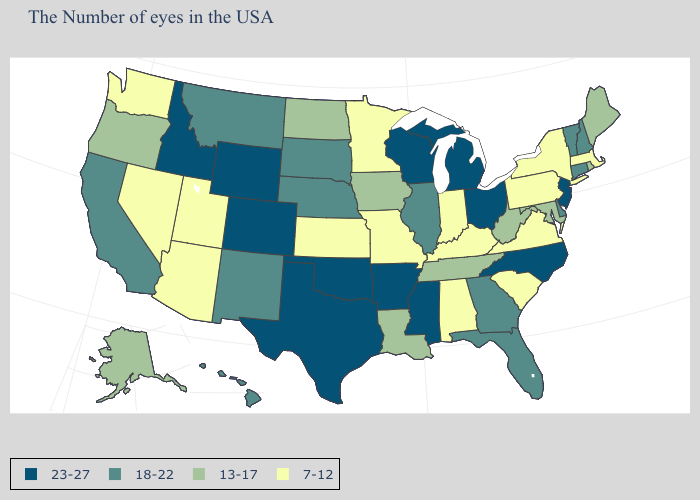Among the states that border North Carolina , does Tennessee have the highest value?
Concise answer only. No. Name the states that have a value in the range 18-22?
Answer briefly. New Hampshire, Vermont, Connecticut, Delaware, Florida, Georgia, Illinois, Nebraska, South Dakota, New Mexico, Montana, California, Hawaii. Which states have the lowest value in the USA?
Write a very short answer. Massachusetts, New York, Pennsylvania, Virginia, South Carolina, Kentucky, Indiana, Alabama, Missouri, Minnesota, Kansas, Utah, Arizona, Nevada, Washington. What is the value of Virginia?
Write a very short answer. 7-12. What is the lowest value in the Northeast?
Short answer required. 7-12. What is the value of Kentucky?
Answer briefly. 7-12. What is the value of Oregon?
Give a very brief answer. 13-17. What is the highest value in the USA?
Keep it brief. 23-27. Name the states that have a value in the range 7-12?
Concise answer only. Massachusetts, New York, Pennsylvania, Virginia, South Carolina, Kentucky, Indiana, Alabama, Missouri, Minnesota, Kansas, Utah, Arizona, Nevada, Washington. Does the first symbol in the legend represent the smallest category?
Give a very brief answer. No. Name the states that have a value in the range 7-12?
Give a very brief answer. Massachusetts, New York, Pennsylvania, Virginia, South Carolina, Kentucky, Indiana, Alabama, Missouri, Minnesota, Kansas, Utah, Arizona, Nevada, Washington. Name the states that have a value in the range 23-27?
Be succinct. New Jersey, North Carolina, Ohio, Michigan, Wisconsin, Mississippi, Arkansas, Oklahoma, Texas, Wyoming, Colorado, Idaho. What is the value of Missouri?
Write a very short answer. 7-12. Name the states that have a value in the range 23-27?
Quick response, please. New Jersey, North Carolina, Ohio, Michigan, Wisconsin, Mississippi, Arkansas, Oklahoma, Texas, Wyoming, Colorado, Idaho. Name the states that have a value in the range 18-22?
Keep it brief. New Hampshire, Vermont, Connecticut, Delaware, Florida, Georgia, Illinois, Nebraska, South Dakota, New Mexico, Montana, California, Hawaii. 